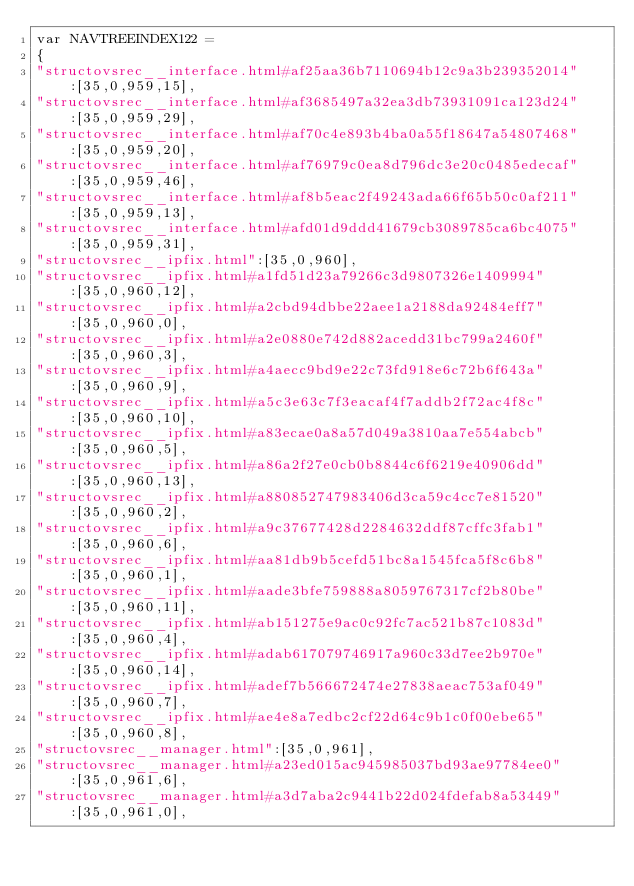<code> <loc_0><loc_0><loc_500><loc_500><_JavaScript_>var NAVTREEINDEX122 =
{
"structovsrec__interface.html#af25aa36b7110694b12c9a3b239352014":[35,0,959,15],
"structovsrec__interface.html#af3685497a32ea3db73931091ca123d24":[35,0,959,29],
"structovsrec__interface.html#af70c4e893b4ba0a55f18647a54807468":[35,0,959,20],
"structovsrec__interface.html#af76979c0ea8d796dc3e20c0485edecaf":[35,0,959,46],
"structovsrec__interface.html#af8b5eac2f49243ada66f65b50c0af211":[35,0,959,13],
"structovsrec__interface.html#afd01d9ddd41679cb3089785ca6bc4075":[35,0,959,31],
"structovsrec__ipfix.html":[35,0,960],
"structovsrec__ipfix.html#a1fd51d23a79266c3d9807326e1409994":[35,0,960,12],
"structovsrec__ipfix.html#a2cbd94dbbe22aee1a2188da92484eff7":[35,0,960,0],
"structovsrec__ipfix.html#a2e0880e742d882acedd31bc799a2460f":[35,0,960,3],
"structovsrec__ipfix.html#a4aecc9bd9e22c73fd918e6c72b6f643a":[35,0,960,9],
"structovsrec__ipfix.html#a5c3e63c7f3eacaf4f7addb2f72ac4f8c":[35,0,960,10],
"structovsrec__ipfix.html#a83ecae0a8a57d049a3810aa7e554abcb":[35,0,960,5],
"structovsrec__ipfix.html#a86a2f27e0cb0b8844c6f6219e40906dd":[35,0,960,13],
"structovsrec__ipfix.html#a880852747983406d3ca59c4cc7e81520":[35,0,960,2],
"structovsrec__ipfix.html#a9c37677428d2284632ddf87cffc3fab1":[35,0,960,6],
"structovsrec__ipfix.html#aa81db9b5cefd51bc8a1545fca5f8c6b8":[35,0,960,1],
"structovsrec__ipfix.html#aade3bfe759888a8059767317cf2b80be":[35,0,960,11],
"structovsrec__ipfix.html#ab151275e9ac0c92fc7ac521b87c1083d":[35,0,960,4],
"structovsrec__ipfix.html#adab617079746917a960c33d7ee2b970e":[35,0,960,14],
"structovsrec__ipfix.html#adef7b566672474e27838aeac753af049":[35,0,960,7],
"structovsrec__ipfix.html#ae4e8a7edbc2cf22d64c9b1c0f00ebe65":[35,0,960,8],
"structovsrec__manager.html":[35,0,961],
"structovsrec__manager.html#a23ed015ac945985037bd93ae97784ee0":[35,0,961,6],
"structovsrec__manager.html#a3d7aba2c9441b22d024fdefab8a53449":[35,0,961,0],</code> 